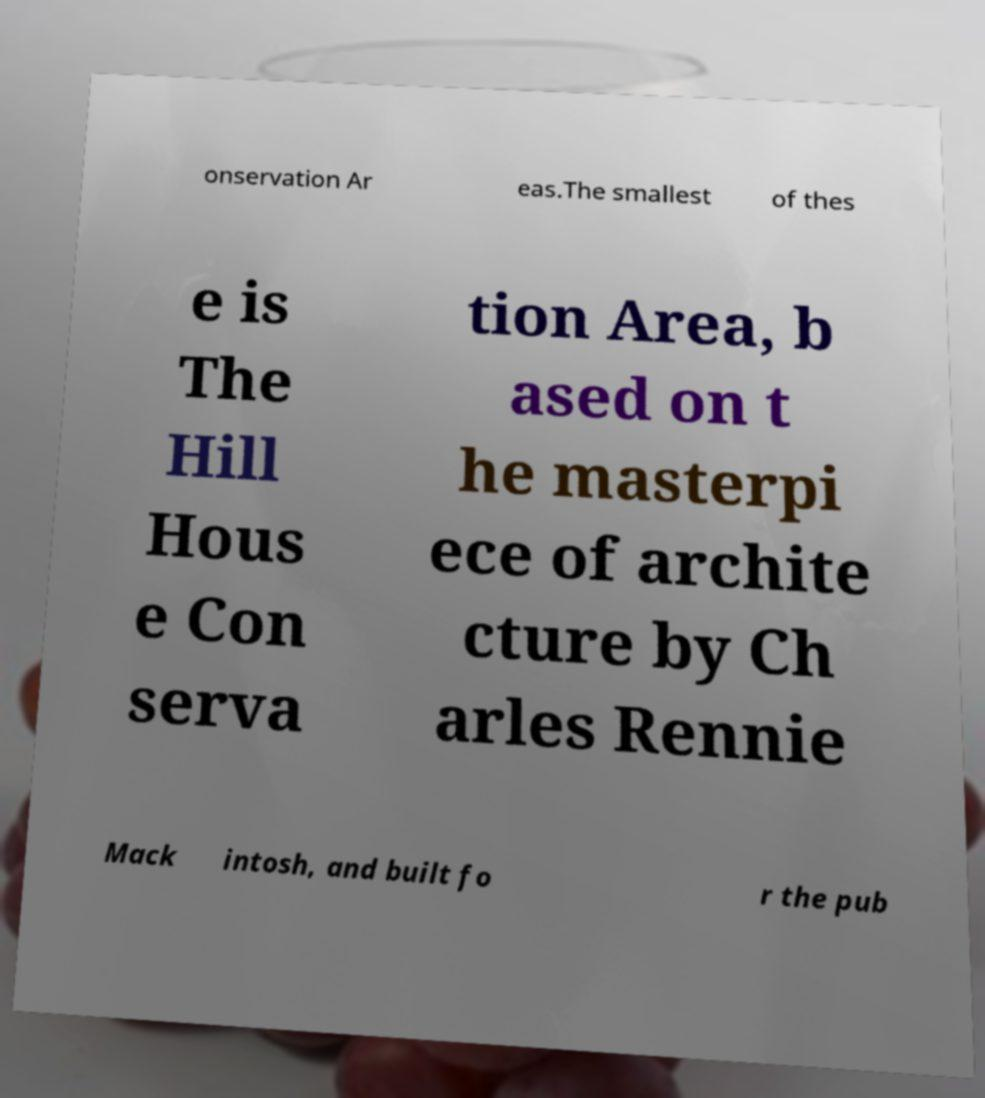There's text embedded in this image that I need extracted. Can you transcribe it verbatim? onservation Ar eas.The smallest of thes e is The Hill Hous e Con serva tion Area, b ased on t he masterpi ece of archite cture by Ch arles Rennie Mack intosh, and built fo r the pub 